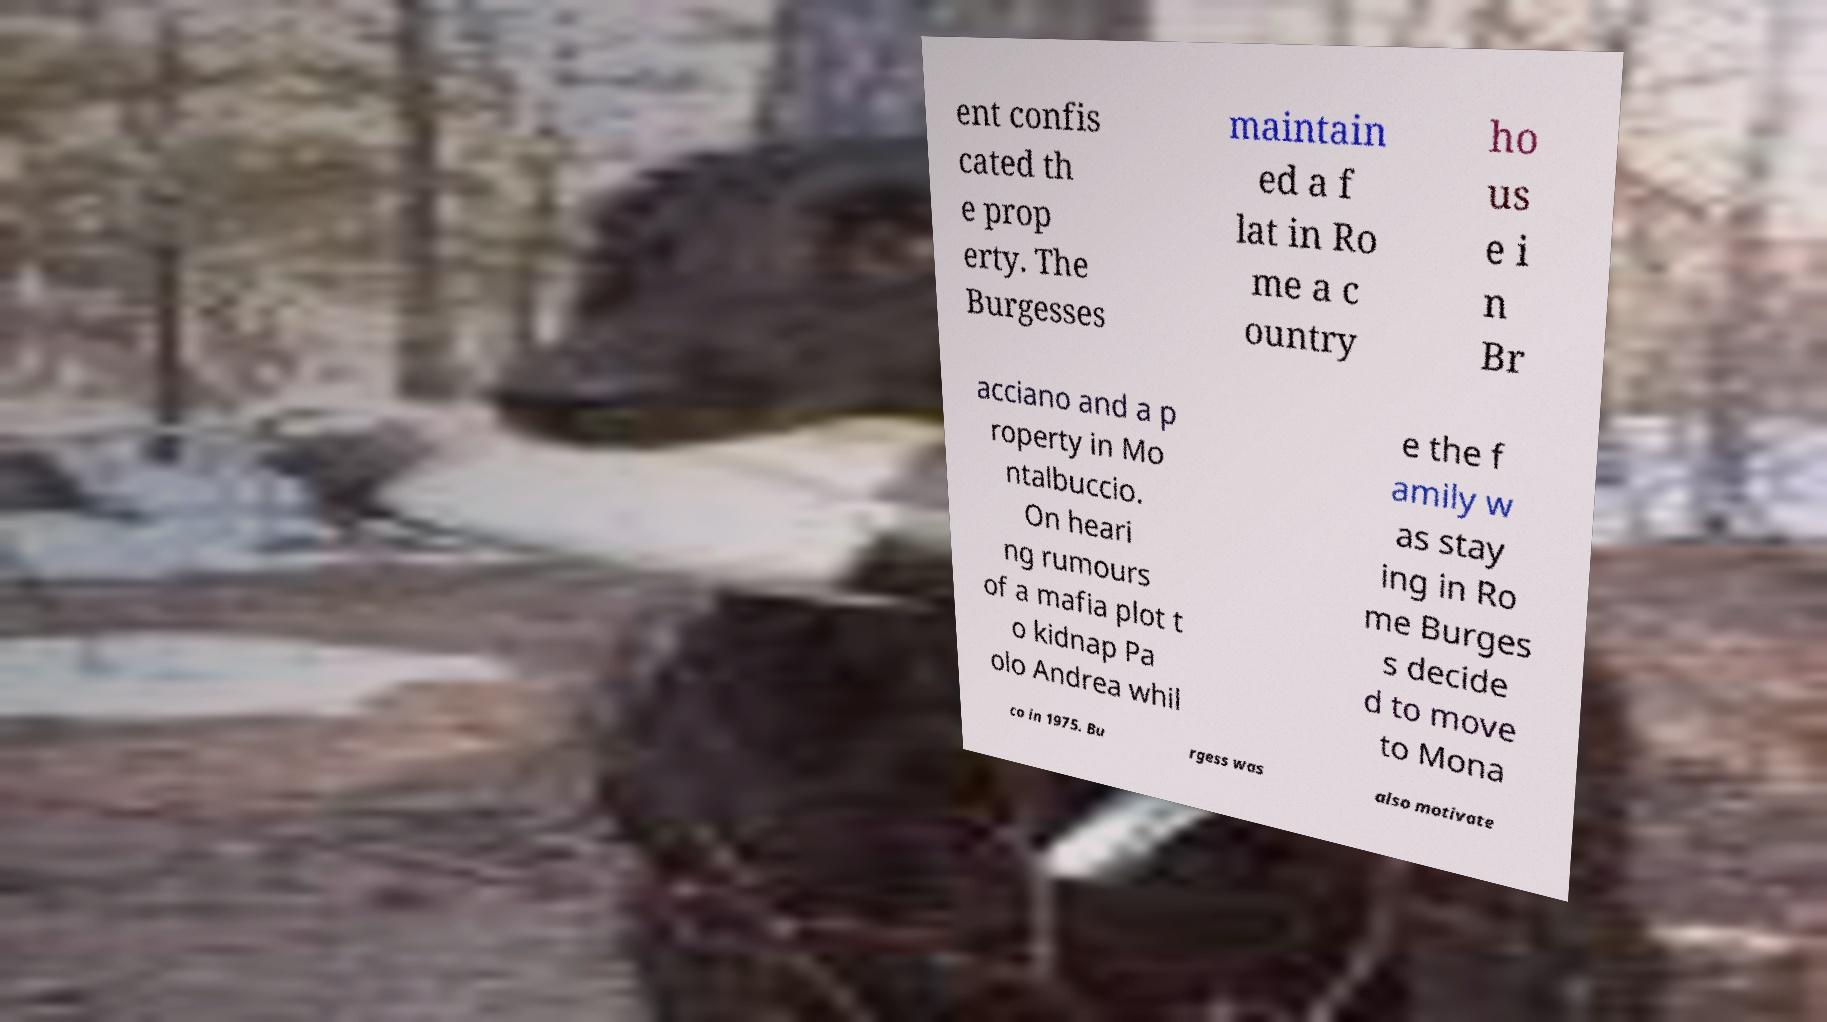Could you extract and type out the text from this image? ent confis cated th e prop erty. The Burgesses maintain ed a f lat in Ro me a c ountry ho us e i n Br acciano and a p roperty in Mo ntalbuccio. On heari ng rumours of a mafia plot t o kidnap Pa olo Andrea whil e the f amily w as stay ing in Ro me Burges s decide d to move to Mona co in 1975. Bu rgess was also motivate 